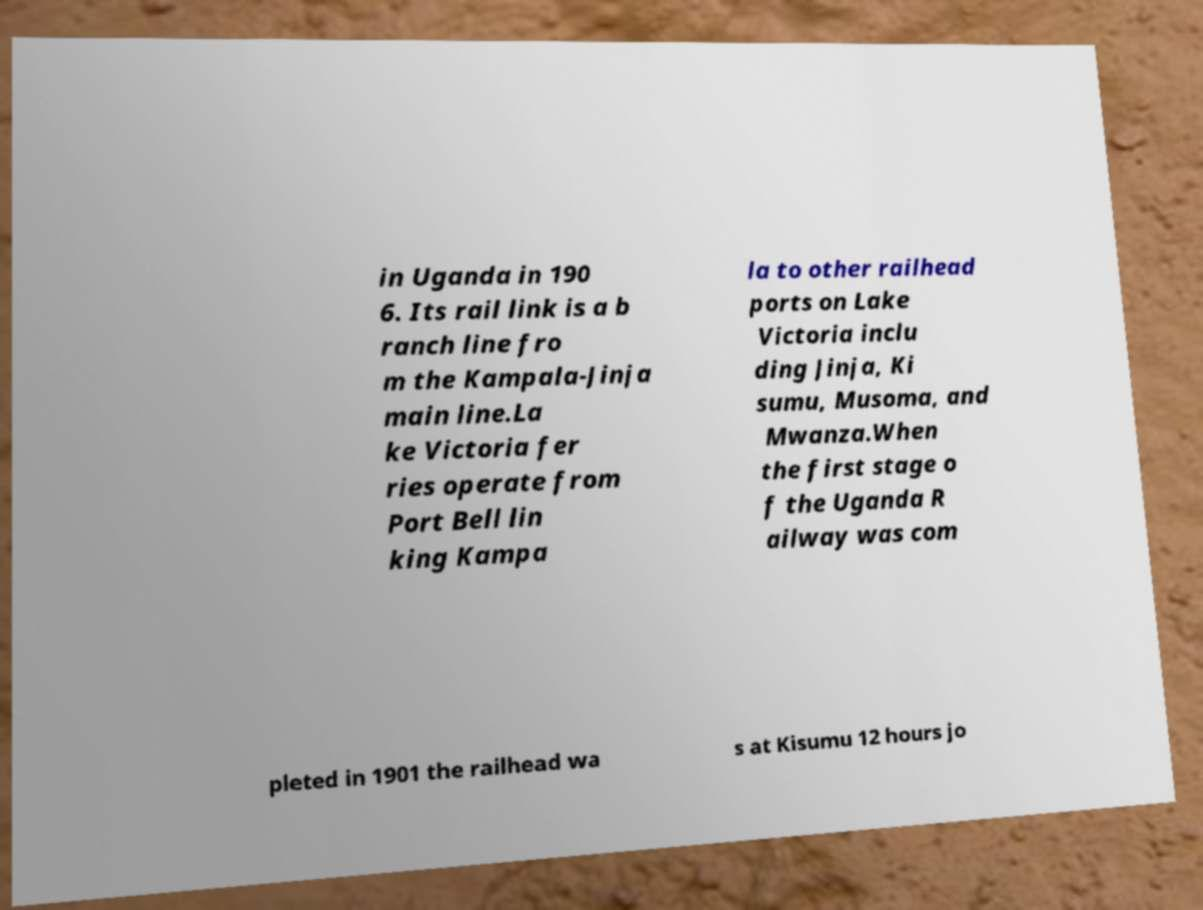What messages or text are displayed in this image? I need them in a readable, typed format. in Uganda in 190 6. Its rail link is a b ranch line fro m the Kampala-Jinja main line.La ke Victoria fer ries operate from Port Bell lin king Kampa la to other railhead ports on Lake Victoria inclu ding Jinja, Ki sumu, Musoma, and Mwanza.When the first stage o f the Uganda R ailway was com pleted in 1901 the railhead wa s at Kisumu 12 hours jo 